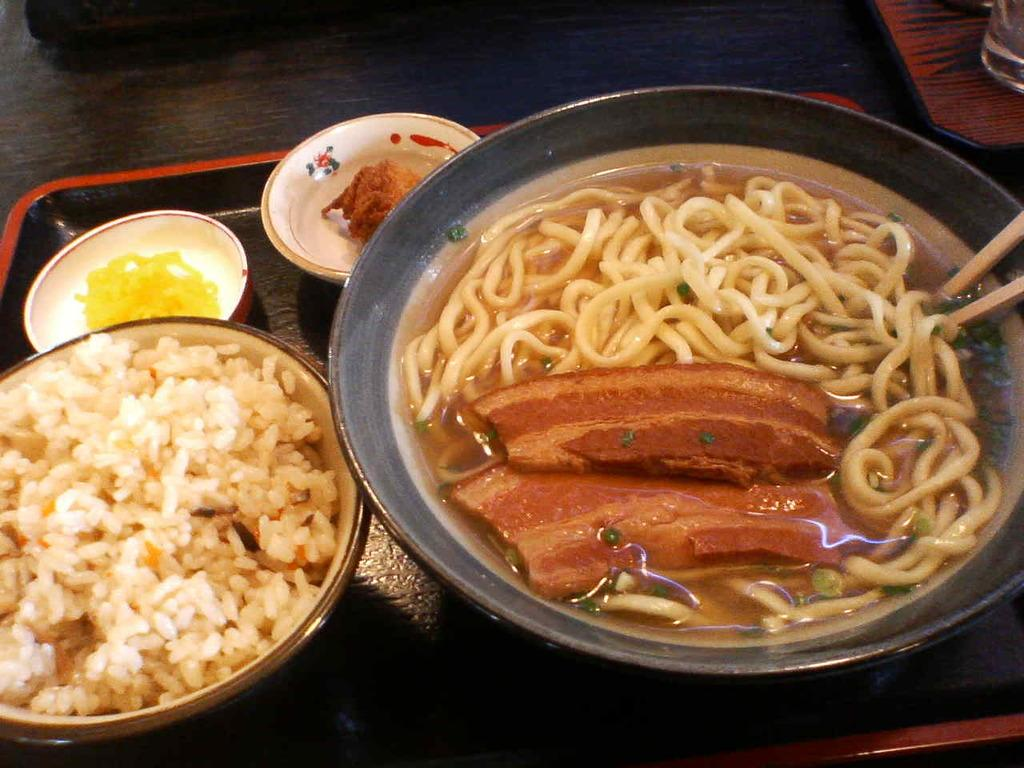What type of food can be seen in the image? There are noodles, meat, and soup in the image. How many chopsticks are visible in the image? There are 2 chopsticks in the image. What type of container is used for the food? There is a bowl in the image. How many bowls with food are present in the image? There are 3 bowls with food in the image. Where are the bowls placed? The bowls are on a tray. Where is the tray located? The tray is on a table. What else can be seen on the table? There is a glass in the image. What type of nerve is visible in the image? There are no nerves present in the image; it features food items and tableware. What type of oven is used to cook the food in the image? There is no oven visible in the image, and the cooking method for the food is not mentioned. 